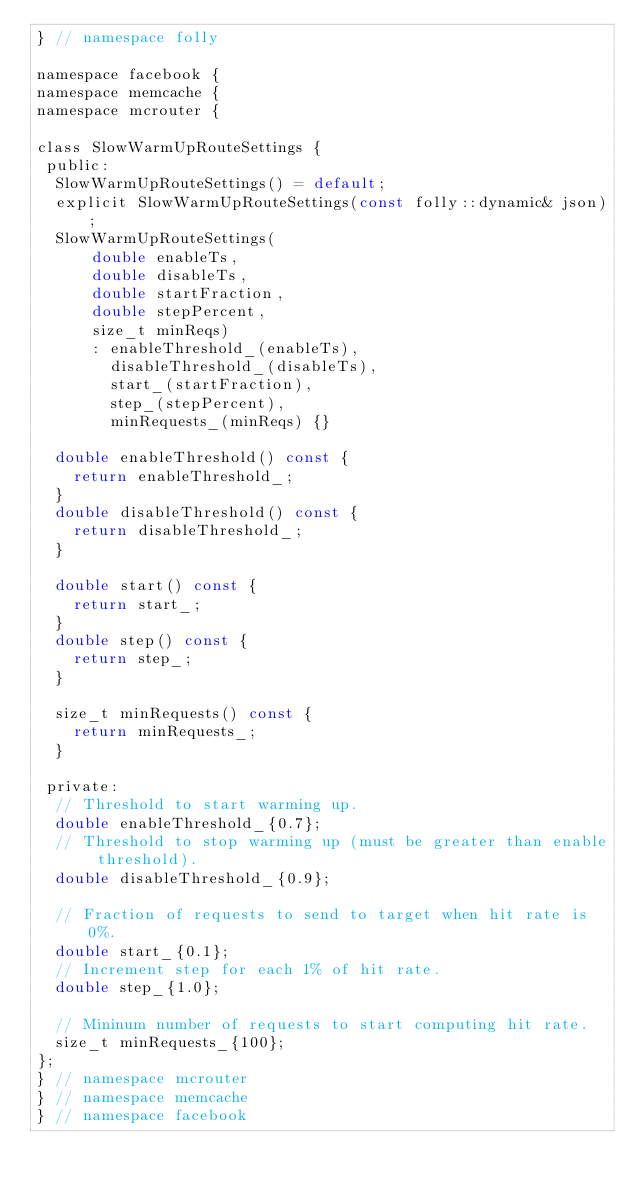<code> <loc_0><loc_0><loc_500><loc_500><_C_>} // namespace folly

namespace facebook {
namespace memcache {
namespace mcrouter {

class SlowWarmUpRouteSettings {
 public:
  SlowWarmUpRouteSettings() = default;
  explicit SlowWarmUpRouteSettings(const folly::dynamic& json);
  SlowWarmUpRouteSettings(
      double enableTs,
      double disableTs,
      double startFraction,
      double stepPercent,
      size_t minReqs)
      : enableThreshold_(enableTs),
        disableThreshold_(disableTs),
        start_(startFraction),
        step_(stepPercent),
        minRequests_(minReqs) {}

  double enableThreshold() const {
    return enableThreshold_;
  }
  double disableThreshold() const {
    return disableThreshold_;
  }

  double start() const {
    return start_;
  }
  double step() const {
    return step_;
  }

  size_t minRequests() const {
    return minRequests_;
  }

 private:
  // Threshold to start warming up.
  double enableThreshold_{0.7};
  // Threshold to stop warming up (must be greater than enable threshold).
  double disableThreshold_{0.9};

  // Fraction of requests to send to target when hit rate is 0%.
  double start_{0.1};
  // Increment step for each 1% of hit rate.
  double step_{1.0};

  // Mininum number of requests to start computing hit rate.
  size_t minRequests_{100};
};
} // namespace mcrouter
} // namespace memcache
} // namespace facebook
</code> 